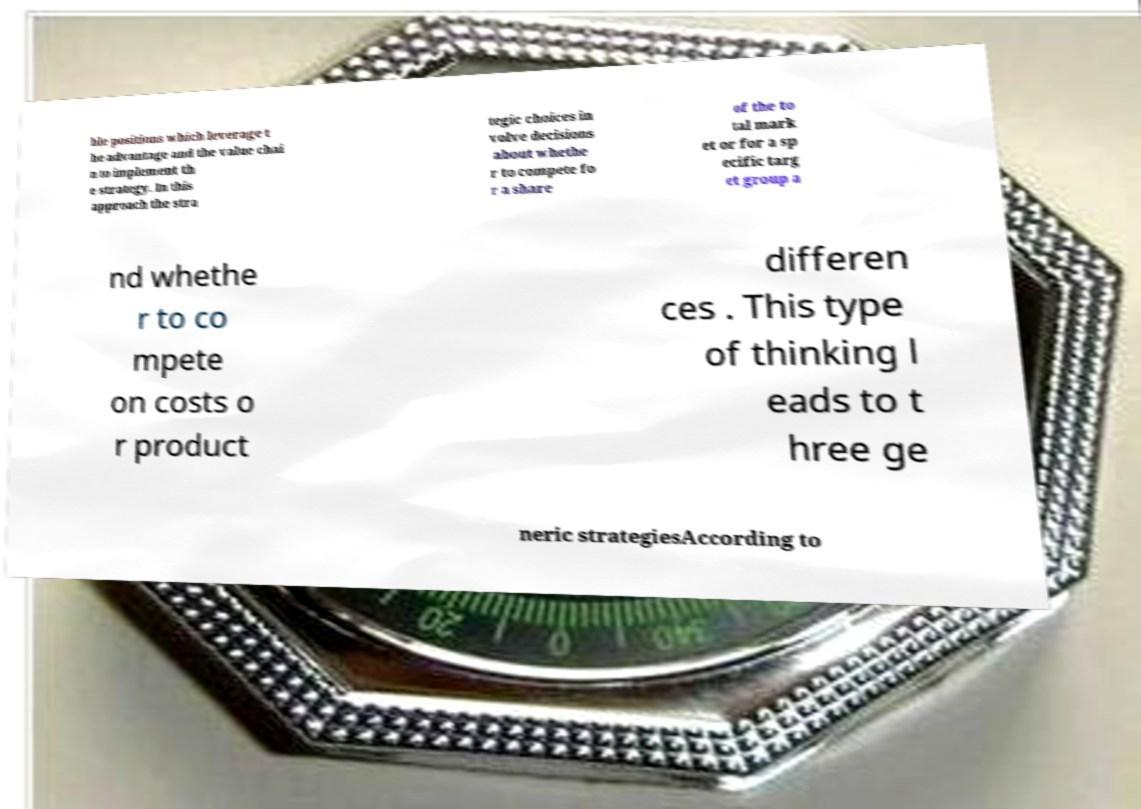Could you assist in decoding the text presented in this image and type it out clearly? ble positions which leverage t he advantage and the value chai n to implement th e strategy. In this approach the stra tegic choices in volve decisions about whethe r to compete fo r a share of the to tal mark et or for a sp ecific targ et group a nd whethe r to co mpete on costs o r product differen ces . This type of thinking l eads to t hree ge neric strategiesAccording to 